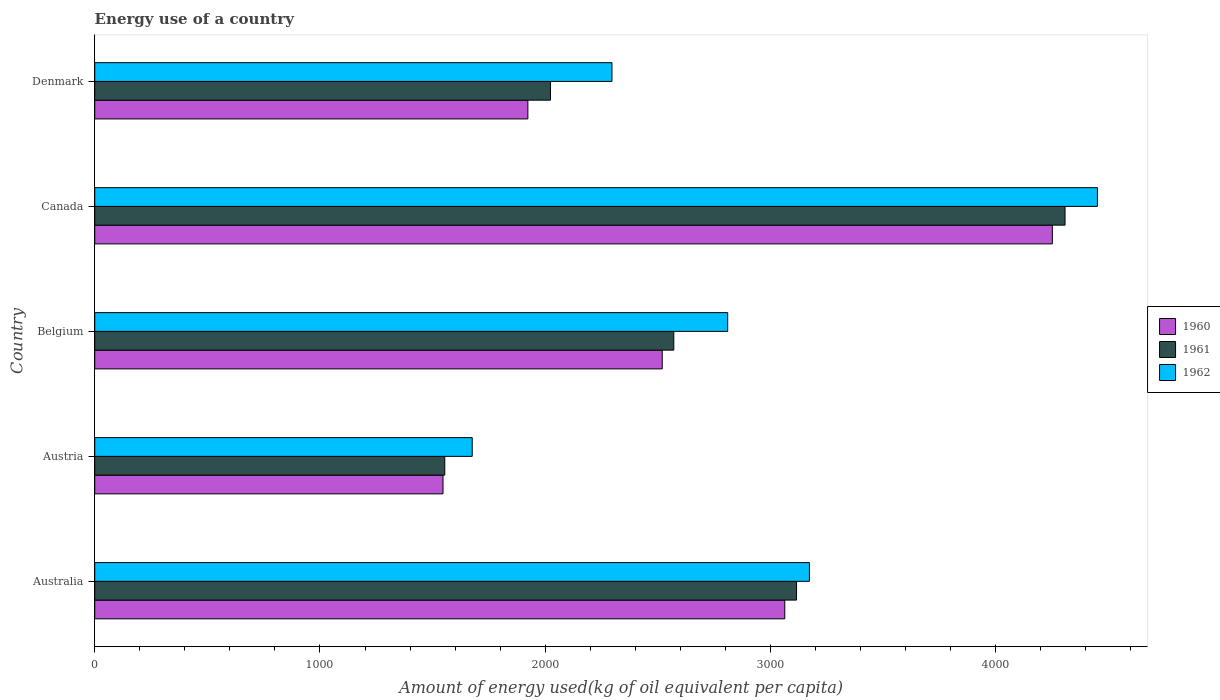Are the number of bars on each tick of the Y-axis equal?
Offer a very short reply. Yes. How many bars are there on the 3rd tick from the top?
Keep it short and to the point. 3. How many bars are there on the 1st tick from the bottom?
Ensure brevity in your answer.  3. In how many cases, is the number of bars for a given country not equal to the number of legend labels?
Keep it short and to the point. 0. What is the amount of energy used in in 1960 in Australia?
Make the answer very short. 3063.55. Across all countries, what is the maximum amount of energy used in in 1960?
Offer a terse response. 4251.44. Across all countries, what is the minimum amount of energy used in in 1961?
Offer a terse response. 1554.03. In which country was the amount of energy used in in 1960 minimum?
Your response must be concise. Austria. What is the total amount of energy used in in 1960 in the graph?
Provide a succinct answer. 1.33e+04. What is the difference between the amount of energy used in in 1962 in Australia and that in Belgium?
Your answer should be very brief. 362.91. What is the difference between the amount of energy used in in 1961 in Denmark and the amount of energy used in in 1962 in Belgium?
Offer a terse response. -786.75. What is the average amount of energy used in in 1961 per country?
Offer a terse response. 2714.35. What is the difference between the amount of energy used in in 1962 and amount of energy used in in 1960 in Canada?
Your answer should be compact. 200.12. In how many countries, is the amount of energy used in in 1960 greater than 200 kg?
Your answer should be compact. 5. What is the ratio of the amount of energy used in in 1961 in Belgium to that in Canada?
Give a very brief answer. 0.6. What is the difference between the highest and the second highest amount of energy used in in 1960?
Ensure brevity in your answer.  1187.88. What is the difference between the highest and the lowest amount of energy used in in 1961?
Offer a very short reply. 2753.79. In how many countries, is the amount of energy used in in 1961 greater than the average amount of energy used in in 1961 taken over all countries?
Your response must be concise. 2. Is the sum of the amount of energy used in in 1961 in Australia and Denmark greater than the maximum amount of energy used in in 1960 across all countries?
Provide a short and direct response. Yes. What does the 1st bar from the top in Australia represents?
Ensure brevity in your answer.  1962. Are all the bars in the graph horizontal?
Offer a very short reply. Yes. How many countries are there in the graph?
Keep it short and to the point. 5. What is the difference between two consecutive major ticks on the X-axis?
Offer a terse response. 1000. Does the graph contain any zero values?
Your response must be concise. No. Does the graph contain grids?
Make the answer very short. No. How many legend labels are there?
Your response must be concise. 3. What is the title of the graph?
Offer a very short reply. Energy use of a country. What is the label or title of the X-axis?
Provide a short and direct response. Amount of energy used(kg of oil equivalent per capita). What is the Amount of energy used(kg of oil equivalent per capita) of 1960 in Australia?
Offer a terse response. 3063.55. What is the Amount of energy used(kg of oil equivalent per capita) of 1961 in Australia?
Ensure brevity in your answer.  3115.79. What is the Amount of energy used(kg of oil equivalent per capita) in 1962 in Australia?
Offer a very short reply. 3172.97. What is the Amount of energy used(kg of oil equivalent per capita) of 1960 in Austria?
Ensure brevity in your answer.  1546.26. What is the Amount of energy used(kg of oil equivalent per capita) of 1961 in Austria?
Keep it short and to the point. 1554.03. What is the Amount of energy used(kg of oil equivalent per capita) of 1962 in Austria?
Your answer should be compact. 1675.87. What is the Amount of energy used(kg of oil equivalent per capita) in 1960 in Belgium?
Your response must be concise. 2519.5. What is the Amount of energy used(kg of oil equivalent per capita) of 1961 in Belgium?
Your response must be concise. 2570.82. What is the Amount of energy used(kg of oil equivalent per capita) in 1962 in Belgium?
Offer a very short reply. 2810.06. What is the Amount of energy used(kg of oil equivalent per capita) in 1960 in Canada?
Your answer should be compact. 4251.44. What is the Amount of energy used(kg of oil equivalent per capita) of 1961 in Canada?
Your answer should be compact. 4307.82. What is the Amount of energy used(kg of oil equivalent per capita) in 1962 in Canada?
Your response must be concise. 4451.56. What is the Amount of energy used(kg of oil equivalent per capita) of 1960 in Denmark?
Offer a terse response. 1922.97. What is the Amount of energy used(kg of oil equivalent per capita) in 1961 in Denmark?
Your response must be concise. 2023.31. What is the Amount of energy used(kg of oil equivalent per capita) of 1962 in Denmark?
Make the answer very short. 2296.29. Across all countries, what is the maximum Amount of energy used(kg of oil equivalent per capita) in 1960?
Your answer should be very brief. 4251.44. Across all countries, what is the maximum Amount of energy used(kg of oil equivalent per capita) of 1961?
Offer a terse response. 4307.82. Across all countries, what is the maximum Amount of energy used(kg of oil equivalent per capita) in 1962?
Keep it short and to the point. 4451.56. Across all countries, what is the minimum Amount of energy used(kg of oil equivalent per capita) in 1960?
Offer a very short reply. 1546.26. Across all countries, what is the minimum Amount of energy used(kg of oil equivalent per capita) of 1961?
Keep it short and to the point. 1554.03. Across all countries, what is the minimum Amount of energy used(kg of oil equivalent per capita) of 1962?
Keep it short and to the point. 1675.87. What is the total Amount of energy used(kg of oil equivalent per capita) of 1960 in the graph?
Your answer should be very brief. 1.33e+04. What is the total Amount of energy used(kg of oil equivalent per capita) in 1961 in the graph?
Your answer should be compact. 1.36e+04. What is the total Amount of energy used(kg of oil equivalent per capita) in 1962 in the graph?
Your answer should be very brief. 1.44e+04. What is the difference between the Amount of energy used(kg of oil equivalent per capita) of 1960 in Australia and that in Austria?
Your answer should be very brief. 1517.29. What is the difference between the Amount of energy used(kg of oil equivalent per capita) of 1961 in Australia and that in Austria?
Offer a very short reply. 1561.75. What is the difference between the Amount of energy used(kg of oil equivalent per capita) of 1962 in Australia and that in Austria?
Provide a short and direct response. 1497.1. What is the difference between the Amount of energy used(kg of oil equivalent per capita) of 1960 in Australia and that in Belgium?
Your answer should be compact. 544.06. What is the difference between the Amount of energy used(kg of oil equivalent per capita) in 1961 in Australia and that in Belgium?
Your answer should be compact. 544.97. What is the difference between the Amount of energy used(kg of oil equivalent per capita) in 1962 in Australia and that in Belgium?
Keep it short and to the point. 362.91. What is the difference between the Amount of energy used(kg of oil equivalent per capita) of 1960 in Australia and that in Canada?
Give a very brief answer. -1187.88. What is the difference between the Amount of energy used(kg of oil equivalent per capita) in 1961 in Australia and that in Canada?
Provide a succinct answer. -1192.03. What is the difference between the Amount of energy used(kg of oil equivalent per capita) of 1962 in Australia and that in Canada?
Offer a terse response. -1278.59. What is the difference between the Amount of energy used(kg of oil equivalent per capita) in 1960 in Australia and that in Denmark?
Give a very brief answer. 1140.58. What is the difference between the Amount of energy used(kg of oil equivalent per capita) of 1961 in Australia and that in Denmark?
Offer a very short reply. 1092.48. What is the difference between the Amount of energy used(kg of oil equivalent per capita) of 1962 in Australia and that in Denmark?
Offer a terse response. 876.69. What is the difference between the Amount of energy used(kg of oil equivalent per capita) in 1960 in Austria and that in Belgium?
Make the answer very short. -973.24. What is the difference between the Amount of energy used(kg of oil equivalent per capita) of 1961 in Austria and that in Belgium?
Give a very brief answer. -1016.78. What is the difference between the Amount of energy used(kg of oil equivalent per capita) in 1962 in Austria and that in Belgium?
Ensure brevity in your answer.  -1134.19. What is the difference between the Amount of energy used(kg of oil equivalent per capita) in 1960 in Austria and that in Canada?
Make the answer very short. -2705.17. What is the difference between the Amount of energy used(kg of oil equivalent per capita) of 1961 in Austria and that in Canada?
Your answer should be compact. -2753.79. What is the difference between the Amount of energy used(kg of oil equivalent per capita) of 1962 in Austria and that in Canada?
Your answer should be very brief. -2775.69. What is the difference between the Amount of energy used(kg of oil equivalent per capita) in 1960 in Austria and that in Denmark?
Provide a short and direct response. -376.71. What is the difference between the Amount of energy used(kg of oil equivalent per capita) in 1961 in Austria and that in Denmark?
Your answer should be compact. -469.27. What is the difference between the Amount of energy used(kg of oil equivalent per capita) of 1962 in Austria and that in Denmark?
Your answer should be very brief. -620.42. What is the difference between the Amount of energy used(kg of oil equivalent per capita) in 1960 in Belgium and that in Canada?
Offer a very short reply. -1731.94. What is the difference between the Amount of energy used(kg of oil equivalent per capita) of 1961 in Belgium and that in Canada?
Your answer should be compact. -1737.01. What is the difference between the Amount of energy used(kg of oil equivalent per capita) of 1962 in Belgium and that in Canada?
Offer a terse response. -1641.5. What is the difference between the Amount of energy used(kg of oil equivalent per capita) in 1960 in Belgium and that in Denmark?
Make the answer very short. 596.52. What is the difference between the Amount of energy used(kg of oil equivalent per capita) of 1961 in Belgium and that in Denmark?
Your answer should be very brief. 547.51. What is the difference between the Amount of energy used(kg of oil equivalent per capita) of 1962 in Belgium and that in Denmark?
Your response must be concise. 513.77. What is the difference between the Amount of energy used(kg of oil equivalent per capita) in 1960 in Canada and that in Denmark?
Give a very brief answer. 2328.46. What is the difference between the Amount of energy used(kg of oil equivalent per capita) of 1961 in Canada and that in Denmark?
Give a very brief answer. 2284.51. What is the difference between the Amount of energy used(kg of oil equivalent per capita) of 1962 in Canada and that in Denmark?
Provide a short and direct response. 2155.27. What is the difference between the Amount of energy used(kg of oil equivalent per capita) in 1960 in Australia and the Amount of energy used(kg of oil equivalent per capita) in 1961 in Austria?
Your response must be concise. 1509.52. What is the difference between the Amount of energy used(kg of oil equivalent per capita) in 1960 in Australia and the Amount of energy used(kg of oil equivalent per capita) in 1962 in Austria?
Keep it short and to the point. 1387.68. What is the difference between the Amount of energy used(kg of oil equivalent per capita) of 1961 in Australia and the Amount of energy used(kg of oil equivalent per capita) of 1962 in Austria?
Your answer should be compact. 1439.91. What is the difference between the Amount of energy used(kg of oil equivalent per capita) in 1960 in Australia and the Amount of energy used(kg of oil equivalent per capita) in 1961 in Belgium?
Keep it short and to the point. 492.74. What is the difference between the Amount of energy used(kg of oil equivalent per capita) of 1960 in Australia and the Amount of energy used(kg of oil equivalent per capita) of 1962 in Belgium?
Your response must be concise. 253.49. What is the difference between the Amount of energy used(kg of oil equivalent per capita) in 1961 in Australia and the Amount of energy used(kg of oil equivalent per capita) in 1962 in Belgium?
Give a very brief answer. 305.73. What is the difference between the Amount of energy used(kg of oil equivalent per capita) of 1960 in Australia and the Amount of energy used(kg of oil equivalent per capita) of 1961 in Canada?
Make the answer very short. -1244.27. What is the difference between the Amount of energy used(kg of oil equivalent per capita) in 1960 in Australia and the Amount of energy used(kg of oil equivalent per capita) in 1962 in Canada?
Your response must be concise. -1388.01. What is the difference between the Amount of energy used(kg of oil equivalent per capita) in 1961 in Australia and the Amount of energy used(kg of oil equivalent per capita) in 1962 in Canada?
Keep it short and to the point. -1335.77. What is the difference between the Amount of energy used(kg of oil equivalent per capita) of 1960 in Australia and the Amount of energy used(kg of oil equivalent per capita) of 1961 in Denmark?
Give a very brief answer. 1040.25. What is the difference between the Amount of energy used(kg of oil equivalent per capita) of 1960 in Australia and the Amount of energy used(kg of oil equivalent per capita) of 1962 in Denmark?
Ensure brevity in your answer.  767.26. What is the difference between the Amount of energy used(kg of oil equivalent per capita) of 1961 in Australia and the Amount of energy used(kg of oil equivalent per capita) of 1962 in Denmark?
Your answer should be very brief. 819.5. What is the difference between the Amount of energy used(kg of oil equivalent per capita) in 1960 in Austria and the Amount of energy used(kg of oil equivalent per capita) in 1961 in Belgium?
Offer a very short reply. -1024.55. What is the difference between the Amount of energy used(kg of oil equivalent per capita) of 1960 in Austria and the Amount of energy used(kg of oil equivalent per capita) of 1962 in Belgium?
Offer a terse response. -1263.8. What is the difference between the Amount of energy used(kg of oil equivalent per capita) of 1961 in Austria and the Amount of energy used(kg of oil equivalent per capita) of 1962 in Belgium?
Make the answer very short. -1256.03. What is the difference between the Amount of energy used(kg of oil equivalent per capita) in 1960 in Austria and the Amount of energy used(kg of oil equivalent per capita) in 1961 in Canada?
Keep it short and to the point. -2761.56. What is the difference between the Amount of energy used(kg of oil equivalent per capita) of 1960 in Austria and the Amount of energy used(kg of oil equivalent per capita) of 1962 in Canada?
Your answer should be very brief. -2905.3. What is the difference between the Amount of energy used(kg of oil equivalent per capita) in 1961 in Austria and the Amount of energy used(kg of oil equivalent per capita) in 1962 in Canada?
Ensure brevity in your answer.  -2897.53. What is the difference between the Amount of energy used(kg of oil equivalent per capita) in 1960 in Austria and the Amount of energy used(kg of oil equivalent per capita) in 1961 in Denmark?
Provide a short and direct response. -477.05. What is the difference between the Amount of energy used(kg of oil equivalent per capita) in 1960 in Austria and the Amount of energy used(kg of oil equivalent per capita) in 1962 in Denmark?
Your answer should be compact. -750.03. What is the difference between the Amount of energy used(kg of oil equivalent per capita) in 1961 in Austria and the Amount of energy used(kg of oil equivalent per capita) in 1962 in Denmark?
Give a very brief answer. -742.25. What is the difference between the Amount of energy used(kg of oil equivalent per capita) of 1960 in Belgium and the Amount of energy used(kg of oil equivalent per capita) of 1961 in Canada?
Provide a short and direct response. -1788.32. What is the difference between the Amount of energy used(kg of oil equivalent per capita) in 1960 in Belgium and the Amount of energy used(kg of oil equivalent per capita) in 1962 in Canada?
Provide a succinct answer. -1932.06. What is the difference between the Amount of energy used(kg of oil equivalent per capita) in 1961 in Belgium and the Amount of energy used(kg of oil equivalent per capita) in 1962 in Canada?
Your answer should be very brief. -1880.74. What is the difference between the Amount of energy used(kg of oil equivalent per capita) in 1960 in Belgium and the Amount of energy used(kg of oil equivalent per capita) in 1961 in Denmark?
Offer a very short reply. 496.19. What is the difference between the Amount of energy used(kg of oil equivalent per capita) in 1960 in Belgium and the Amount of energy used(kg of oil equivalent per capita) in 1962 in Denmark?
Ensure brevity in your answer.  223.21. What is the difference between the Amount of energy used(kg of oil equivalent per capita) in 1961 in Belgium and the Amount of energy used(kg of oil equivalent per capita) in 1962 in Denmark?
Provide a succinct answer. 274.53. What is the difference between the Amount of energy used(kg of oil equivalent per capita) of 1960 in Canada and the Amount of energy used(kg of oil equivalent per capita) of 1961 in Denmark?
Provide a succinct answer. 2228.13. What is the difference between the Amount of energy used(kg of oil equivalent per capita) of 1960 in Canada and the Amount of energy used(kg of oil equivalent per capita) of 1962 in Denmark?
Keep it short and to the point. 1955.15. What is the difference between the Amount of energy used(kg of oil equivalent per capita) of 1961 in Canada and the Amount of energy used(kg of oil equivalent per capita) of 1962 in Denmark?
Offer a terse response. 2011.53. What is the average Amount of energy used(kg of oil equivalent per capita) in 1960 per country?
Give a very brief answer. 2660.74. What is the average Amount of energy used(kg of oil equivalent per capita) in 1961 per country?
Offer a very short reply. 2714.35. What is the average Amount of energy used(kg of oil equivalent per capita) of 1962 per country?
Make the answer very short. 2881.35. What is the difference between the Amount of energy used(kg of oil equivalent per capita) of 1960 and Amount of energy used(kg of oil equivalent per capita) of 1961 in Australia?
Provide a succinct answer. -52.23. What is the difference between the Amount of energy used(kg of oil equivalent per capita) of 1960 and Amount of energy used(kg of oil equivalent per capita) of 1962 in Australia?
Ensure brevity in your answer.  -109.42. What is the difference between the Amount of energy used(kg of oil equivalent per capita) in 1961 and Amount of energy used(kg of oil equivalent per capita) in 1962 in Australia?
Offer a very short reply. -57.19. What is the difference between the Amount of energy used(kg of oil equivalent per capita) of 1960 and Amount of energy used(kg of oil equivalent per capita) of 1961 in Austria?
Keep it short and to the point. -7.77. What is the difference between the Amount of energy used(kg of oil equivalent per capita) of 1960 and Amount of energy used(kg of oil equivalent per capita) of 1962 in Austria?
Your response must be concise. -129.61. What is the difference between the Amount of energy used(kg of oil equivalent per capita) of 1961 and Amount of energy used(kg of oil equivalent per capita) of 1962 in Austria?
Offer a very short reply. -121.84. What is the difference between the Amount of energy used(kg of oil equivalent per capita) in 1960 and Amount of energy used(kg of oil equivalent per capita) in 1961 in Belgium?
Offer a terse response. -51.32. What is the difference between the Amount of energy used(kg of oil equivalent per capita) in 1960 and Amount of energy used(kg of oil equivalent per capita) in 1962 in Belgium?
Your response must be concise. -290.56. What is the difference between the Amount of energy used(kg of oil equivalent per capita) of 1961 and Amount of energy used(kg of oil equivalent per capita) of 1962 in Belgium?
Offer a very short reply. -239.25. What is the difference between the Amount of energy used(kg of oil equivalent per capita) of 1960 and Amount of energy used(kg of oil equivalent per capita) of 1961 in Canada?
Provide a succinct answer. -56.38. What is the difference between the Amount of energy used(kg of oil equivalent per capita) in 1960 and Amount of energy used(kg of oil equivalent per capita) in 1962 in Canada?
Offer a terse response. -200.12. What is the difference between the Amount of energy used(kg of oil equivalent per capita) of 1961 and Amount of energy used(kg of oil equivalent per capita) of 1962 in Canada?
Your answer should be very brief. -143.74. What is the difference between the Amount of energy used(kg of oil equivalent per capita) in 1960 and Amount of energy used(kg of oil equivalent per capita) in 1961 in Denmark?
Your answer should be very brief. -100.33. What is the difference between the Amount of energy used(kg of oil equivalent per capita) of 1960 and Amount of energy used(kg of oil equivalent per capita) of 1962 in Denmark?
Your response must be concise. -373.32. What is the difference between the Amount of energy used(kg of oil equivalent per capita) in 1961 and Amount of energy used(kg of oil equivalent per capita) in 1962 in Denmark?
Keep it short and to the point. -272.98. What is the ratio of the Amount of energy used(kg of oil equivalent per capita) of 1960 in Australia to that in Austria?
Your response must be concise. 1.98. What is the ratio of the Amount of energy used(kg of oil equivalent per capita) of 1961 in Australia to that in Austria?
Offer a very short reply. 2. What is the ratio of the Amount of energy used(kg of oil equivalent per capita) of 1962 in Australia to that in Austria?
Give a very brief answer. 1.89. What is the ratio of the Amount of energy used(kg of oil equivalent per capita) of 1960 in Australia to that in Belgium?
Offer a terse response. 1.22. What is the ratio of the Amount of energy used(kg of oil equivalent per capita) of 1961 in Australia to that in Belgium?
Your answer should be compact. 1.21. What is the ratio of the Amount of energy used(kg of oil equivalent per capita) in 1962 in Australia to that in Belgium?
Make the answer very short. 1.13. What is the ratio of the Amount of energy used(kg of oil equivalent per capita) in 1960 in Australia to that in Canada?
Provide a succinct answer. 0.72. What is the ratio of the Amount of energy used(kg of oil equivalent per capita) in 1961 in Australia to that in Canada?
Your answer should be very brief. 0.72. What is the ratio of the Amount of energy used(kg of oil equivalent per capita) of 1962 in Australia to that in Canada?
Give a very brief answer. 0.71. What is the ratio of the Amount of energy used(kg of oil equivalent per capita) in 1960 in Australia to that in Denmark?
Make the answer very short. 1.59. What is the ratio of the Amount of energy used(kg of oil equivalent per capita) in 1961 in Australia to that in Denmark?
Offer a terse response. 1.54. What is the ratio of the Amount of energy used(kg of oil equivalent per capita) of 1962 in Australia to that in Denmark?
Give a very brief answer. 1.38. What is the ratio of the Amount of energy used(kg of oil equivalent per capita) in 1960 in Austria to that in Belgium?
Offer a terse response. 0.61. What is the ratio of the Amount of energy used(kg of oil equivalent per capita) of 1961 in Austria to that in Belgium?
Your answer should be compact. 0.6. What is the ratio of the Amount of energy used(kg of oil equivalent per capita) of 1962 in Austria to that in Belgium?
Your answer should be compact. 0.6. What is the ratio of the Amount of energy used(kg of oil equivalent per capita) in 1960 in Austria to that in Canada?
Provide a succinct answer. 0.36. What is the ratio of the Amount of energy used(kg of oil equivalent per capita) of 1961 in Austria to that in Canada?
Keep it short and to the point. 0.36. What is the ratio of the Amount of energy used(kg of oil equivalent per capita) in 1962 in Austria to that in Canada?
Provide a short and direct response. 0.38. What is the ratio of the Amount of energy used(kg of oil equivalent per capita) in 1960 in Austria to that in Denmark?
Provide a succinct answer. 0.8. What is the ratio of the Amount of energy used(kg of oil equivalent per capita) of 1961 in Austria to that in Denmark?
Offer a very short reply. 0.77. What is the ratio of the Amount of energy used(kg of oil equivalent per capita) of 1962 in Austria to that in Denmark?
Make the answer very short. 0.73. What is the ratio of the Amount of energy used(kg of oil equivalent per capita) of 1960 in Belgium to that in Canada?
Keep it short and to the point. 0.59. What is the ratio of the Amount of energy used(kg of oil equivalent per capita) in 1961 in Belgium to that in Canada?
Make the answer very short. 0.6. What is the ratio of the Amount of energy used(kg of oil equivalent per capita) of 1962 in Belgium to that in Canada?
Your response must be concise. 0.63. What is the ratio of the Amount of energy used(kg of oil equivalent per capita) in 1960 in Belgium to that in Denmark?
Your answer should be very brief. 1.31. What is the ratio of the Amount of energy used(kg of oil equivalent per capita) of 1961 in Belgium to that in Denmark?
Provide a short and direct response. 1.27. What is the ratio of the Amount of energy used(kg of oil equivalent per capita) in 1962 in Belgium to that in Denmark?
Ensure brevity in your answer.  1.22. What is the ratio of the Amount of energy used(kg of oil equivalent per capita) of 1960 in Canada to that in Denmark?
Your answer should be compact. 2.21. What is the ratio of the Amount of energy used(kg of oil equivalent per capita) in 1961 in Canada to that in Denmark?
Your response must be concise. 2.13. What is the ratio of the Amount of energy used(kg of oil equivalent per capita) of 1962 in Canada to that in Denmark?
Make the answer very short. 1.94. What is the difference between the highest and the second highest Amount of energy used(kg of oil equivalent per capita) of 1960?
Give a very brief answer. 1187.88. What is the difference between the highest and the second highest Amount of energy used(kg of oil equivalent per capita) of 1961?
Your response must be concise. 1192.03. What is the difference between the highest and the second highest Amount of energy used(kg of oil equivalent per capita) of 1962?
Give a very brief answer. 1278.59. What is the difference between the highest and the lowest Amount of energy used(kg of oil equivalent per capita) in 1960?
Your answer should be compact. 2705.17. What is the difference between the highest and the lowest Amount of energy used(kg of oil equivalent per capita) of 1961?
Your response must be concise. 2753.79. What is the difference between the highest and the lowest Amount of energy used(kg of oil equivalent per capita) of 1962?
Your response must be concise. 2775.69. 